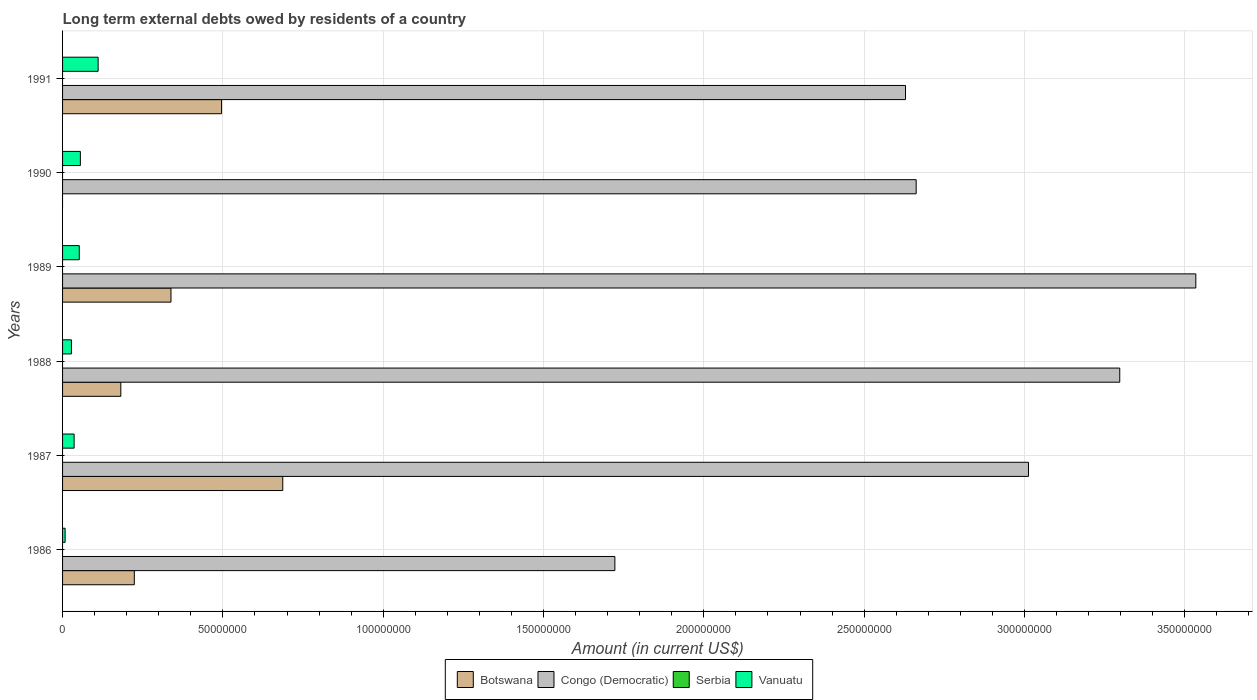How many groups of bars are there?
Ensure brevity in your answer.  6. Are the number of bars on each tick of the Y-axis equal?
Ensure brevity in your answer.  No. How many bars are there on the 4th tick from the bottom?
Give a very brief answer. 3. In how many cases, is the number of bars for a given year not equal to the number of legend labels?
Your response must be concise. 6. What is the amount of long-term external debts owed by residents in Vanuatu in 1986?
Your answer should be compact. 7.98e+05. Across all years, what is the maximum amount of long-term external debts owed by residents in Botswana?
Your response must be concise. 6.87e+07. Across all years, what is the minimum amount of long-term external debts owed by residents in Vanuatu?
Offer a very short reply. 7.98e+05. What is the total amount of long-term external debts owed by residents in Congo (Democratic) in the graph?
Ensure brevity in your answer.  1.69e+09. What is the difference between the amount of long-term external debts owed by residents in Botswana in 1988 and that in 1991?
Your answer should be very brief. -3.14e+07. What is the difference between the amount of long-term external debts owed by residents in Serbia in 1987 and the amount of long-term external debts owed by residents in Congo (Democratic) in 1986?
Your answer should be compact. -1.72e+08. What is the average amount of long-term external debts owed by residents in Vanuatu per year?
Give a very brief answer. 4.84e+06. In the year 1991, what is the difference between the amount of long-term external debts owed by residents in Vanuatu and amount of long-term external debts owed by residents in Botswana?
Give a very brief answer. -3.85e+07. In how many years, is the amount of long-term external debts owed by residents in Vanuatu greater than 10000000 US$?
Your answer should be very brief. 1. What is the ratio of the amount of long-term external debts owed by residents in Congo (Democratic) in 1987 to that in 1990?
Your answer should be very brief. 1.13. What is the difference between the highest and the second highest amount of long-term external debts owed by residents in Botswana?
Your answer should be compact. 1.91e+07. What is the difference between the highest and the lowest amount of long-term external debts owed by residents in Vanuatu?
Your response must be concise. 1.03e+07. In how many years, is the amount of long-term external debts owed by residents in Serbia greater than the average amount of long-term external debts owed by residents in Serbia taken over all years?
Offer a terse response. 0. Is the sum of the amount of long-term external debts owed by residents in Congo (Democratic) in 1987 and 1989 greater than the maximum amount of long-term external debts owed by residents in Serbia across all years?
Give a very brief answer. Yes. How many bars are there?
Ensure brevity in your answer.  17. Does the graph contain any zero values?
Ensure brevity in your answer.  Yes. How many legend labels are there?
Your answer should be compact. 4. How are the legend labels stacked?
Make the answer very short. Horizontal. What is the title of the graph?
Keep it short and to the point. Long term external debts owed by residents of a country. Does "Channel Islands" appear as one of the legend labels in the graph?
Make the answer very short. No. What is the label or title of the Y-axis?
Make the answer very short. Years. What is the Amount (in current US$) of Botswana in 1986?
Your response must be concise. 2.24e+07. What is the Amount (in current US$) in Congo (Democratic) in 1986?
Ensure brevity in your answer.  1.72e+08. What is the Amount (in current US$) of Vanuatu in 1986?
Make the answer very short. 7.98e+05. What is the Amount (in current US$) in Botswana in 1987?
Offer a terse response. 6.87e+07. What is the Amount (in current US$) of Congo (Democratic) in 1987?
Ensure brevity in your answer.  3.01e+08. What is the Amount (in current US$) in Vanuatu in 1987?
Offer a terse response. 3.60e+06. What is the Amount (in current US$) of Botswana in 1988?
Provide a short and direct response. 1.82e+07. What is the Amount (in current US$) in Congo (Democratic) in 1988?
Keep it short and to the point. 3.30e+08. What is the Amount (in current US$) in Serbia in 1988?
Your response must be concise. 0. What is the Amount (in current US$) of Vanuatu in 1988?
Offer a terse response. 2.76e+06. What is the Amount (in current US$) in Botswana in 1989?
Your answer should be compact. 3.38e+07. What is the Amount (in current US$) of Congo (Democratic) in 1989?
Give a very brief answer. 3.53e+08. What is the Amount (in current US$) of Vanuatu in 1989?
Offer a very short reply. 5.21e+06. What is the Amount (in current US$) in Botswana in 1990?
Your answer should be compact. 0. What is the Amount (in current US$) in Congo (Democratic) in 1990?
Your answer should be compact. 2.66e+08. What is the Amount (in current US$) of Vanuatu in 1990?
Keep it short and to the point. 5.56e+06. What is the Amount (in current US$) of Botswana in 1991?
Your response must be concise. 4.96e+07. What is the Amount (in current US$) in Congo (Democratic) in 1991?
Your response must be concise. 2.63e+08. What is the Amount (in current US$) in Vanuatu in 1991?
Your response must be concise. 1.11e+07. Across all years, what is the maximum Amount (in current US$) of Botswana?
Provide a short and direct response. 6.87e+07. Across all years, what is the maximum Amount (in current US$) of Congo (Democratic)?
Your answer should be compact. 3.53e+08. Across all years, what is the maximum Amount (in current US$) in Vanuatu?
Ensure brevity in your answer.  1.11e+07. Across all years, what is the minimum Amount (in current US$) in Congo (Democratic)?
Your answer should be very brief. 1.72e+08. Across all years, what is the minimum Amount (in current US$) in Vanuatu?
Give a very brief answer. 7.98e+05. What is the total Amount (in current US$) in Botswana in the graph?
Ensure brevity in your answer.  1.93e+08. What is the total Amount (in current US$) in Congo (Democratic) in the graph?
Offer a terse response. 1.69e+09. What is the total Amount (in current US$) of Vanuatu in the graph?
Your response must be concise. 2.90e+07. What is the difference between the Amount (in current US$) of Botswana in 1986 and that in 1987?
Make the answer very short. -4.63e+07. What is the difference between the Amount (in current US$) in Congo (Democratic) in 1986 and that in 1987?
Keep it short and to the point. -1.29e+08. What is the difference between the Amount (in current US$) in Vanuatu in 1986 and that in 1987?
Your response must be concise. -2.81e+06. What is the difference between the Amount (in current US$) in Botswana in 1986 and that in 1988?
Provide a short and direct response. 4.21e+06. What is the difference between the Amount (in current US$) of Congo (Democratic) in 1986 and that in 1988?
Your response must be concise. -1.57e+08. What is the difference between the Amount (in current US$) in Vanuatu in 1986 and that in 1988?
Ensure brevity in your answer.  -1.96e+06. What is the difference between the Amount (in current US$) of Botswana in 1986 and that in 1989?
Make the answer very short. -1.14e+07. What is the difference between the Amount (in current US$) of Congo (Democratic) in 1986 and that in 1989?
Your response must be concise. -1.81e+08. What is the difference between the Amount (in current US$) of Vanuatu in 1986 and that in 1989?
Your response must be concise. -4.41e+06. What is the difference between the Amount (in current US$) in Congo (Democratic) in 1986 and that in 1990?
Keep it short and to the point. -9.40e+07. What is the difference between the Amount (in current US$) of Vanuatu in 1986 and that in 1990?
Provide a succinct answer. -4.76e+06. What is the difference between the Amount (in current US$) of Botswana in 1986 and that in 1991?
Ensure brevity in your answer.  -2.72e+07. What is the difference between the Amount (in current US$) in Congo (Democratic) in 1986 and that in 1991?
Your response must be concise. -9.06e+07. What is the difference between the Amount (in current US$) of Vanuatu in 1986 and that in 1991?
Provide a short and direct response. -1.03e+07. What is the difference between the Amount (in current US$) of Botswana in 1987 and that in 1988?
Your answer should be very brief. 5.05e+07. What is the difference between the Amount (in current US$) in Congo (Democratic) in 1987 and that in 1988?
Offer a terse response. -2.85e+07. What is the difference between the Amount (in current US$) of Vanuatu in 1987 and that in 1988?
Your answer should be very brief. 8.45e+05. What is the difference between the Amount (in current US$) in Botswana in 1987 and that in 1989?
Ensure brevity in your answer.  3.49e+07. What is the difference between the Amount (in current US$) in Congo (Democratic) in 1987 and that in 1989?
Keep it short and to the point. -5.22e+07. What is the difference between the Amount (in current US$) in Vanuatu in 1987 and that in 1989?
Offer a terse response. -1.60e+06. What is the difference between the Amount (in current US$) of Congo (Democratic) in 1987 and that in 1990?
Offer a very short reply. 3.50e+07. What is the difference between the Amount (in current US$) of Vanuatu in 1987 and that in 1990?
Your response must be concise. -1.95e+06. What is the difference between the Amount (in current US$) of Botswana in 1987 and that in 1991?
Make the answer very short. 1.91e+07. What is the difference between the Amount (in current US$) in Congo (Democratic) in 1987 and that in 1991?
Your answer should be very brief. 3.83e+07. What is the difference between the Amount (in current US$) in Vanuatu in 1987 and that in 1991?
Make the answer very short. -7.49e+06. What is the difference between the Amount (in current US$) of Botswana in 1988 and that in 1989?
Provide a succinct answer. -1.56e+07. What is the difference between the Amount (in current US$) of Congo (Democratic) in 1988 and that in 1989?
Ensure brevity in your answer.  -2.37e+07. What is the difference between the Amount (in current US$) in Vanuatu in 1988 and that in 1989?
Keep it short and to the point. -2.45e+06. What is the difference between the Amount (in current US$) in Congo (Democratic) in 1988 and that in 1990?
Ensure brevity in your answer.  6.35e+07. What is the difference between the Amount (in current US$) in Vanuatu in 1988 and that in 1990?
Your answer should be very brief. -2.80e+06. What is the difference between the Amount (in current US$) in Botswana in 1988 and that in 1991?
Keep it short and to the point. -3.14e+07. What is the difference between the Amount (in current US$) in Congo (Democratic) in 1988 and that in 1991?
Your response must be concise. 6.68e+07. What is the difference between the Amount (in current US$) of Vanuatu in 1988 and that in 1991?
Offer a terse response. -8.33e+06. What is the difference between the Amount (in current US$) in Congo (Democratic) in 1989 and that in 1990?
Provide a short and direct response. 8.72e+07. What is the difference between the Amount (in current US$) in Vanuatu in 1989 and that in 1990?
Offer a very short reply. -3.47e+05. What is the difference between the Amount (in current US$) in Botswana in 1989 and that in 1991?
Provide a succinct answer. -1.58e+07. What is the difference between the Amount (in current US$) of Congo (Democratic) in 1989 and that in 1991?
Your answer should be very brief. 9.05e+07. What is the difference between the Amount (in current US$) in Vanuatu in 1989 and that in 1991?
Keep it short and to the point. -5.89e+06. What is the difference between the Amount (in current US$) of Congo (Democratic) in 1990 and that in 1991?
Offer a terse response. 3.32e+06. What is the difference between the Amount (in current US$) in Vanuatu in 1990 and that in 1991?
Provide a short and direct response. -5.54e+06. What is the difference between the Amount (in current US$) in Botswana in 1986 and the Amount (in current US$) in Congo (Democratic) in 1987?
Give a very brief answer. -2.79e+08. What is the difference between the Amount (in current US$) of Botswana in 1986 and the Amount (in current US$) of Vanuatu in 1987?
Your response must be concise. 1.88e+07. What is the difference between the Amount (in current US$) of Congo (Democratic) in 1986 and the Amount (in current US$) of Vanuatu in 1987?
Your answer should be compact. 1.69e+08. What is the difference between the Amount (in current US$) in Botswana in 1986 and the Amount (in current US$) in Congo (Democratic) in 1988?
Your answer should be compact. -3.07e+08. What is the difference between the Amount (in current US$) in Botswana in 1986 and the Amount (in current US$) in Vanuatu in 1988?
Offer a terse response. 1.96e+07. What is the difference between the Amount (in current US$) of Congo (Democratic) in 1986 and the Amount (in current US$) of Vanuatu in 1988?
Offer a very short reply. 1.69e+08. What is the difference between the Amount (in current US$) in Botswana in 1986 and the Amount (in current US$) in Congo (Democratic) in 1989?
Your response must be concise. -3.31e+08. What is the difference between the Amount (in current US$) of Botswana in 1986 and the Amount (in current US$) of Vanuatu in 1989?
Keep it short and to the point. 1.72e+07. What is the difference between the Amount (in current US$) in Congo (Democratic) in 1986 and the Amount (in current US$) in Vanuatu in 1989?
Give a very brief answer. 1.67e+08. What is the difference between the Amount (in current US$) in Botswana in 1986 and the Amount (in current US$) in Congo (Democratic) in 1990?
Offer a very short reply. -2.44e+08. What is the difference between the Amount (in current US$) of Botswana in 1986 and the Amount (in current US$) of Vanuatu in 1990?
Your response must be concise. 1.68e+07. What is the difference between the Amount (in current US$) in Congo (Democratic) in 1986 and the Amount (in current US$) in Vanuatu in 1990?
Ensure brevity in your answer.  1.67e+08. What is the difference between the Amount (in current US$) of Botswana in 1986 and the Amount (in current US$) of Congo (Democratic) in 1991?
Your response must be concise. -2.41e+08. What is the difference between the Amount (in current US$) in Botswana in 1986 and the Amount (in current US$) in Vanuatu in 1991?
Your answer should be compact. 1.13e+07. What is the difference between the Amount (in current US$) of Congo (Democratic) in 1986 and the Amount (in current US$) of Vanuatu in 1991?
Your answer should be compact. 1.61e+08. What is the difference between the Amount (in current US$) in Botswana in 1987 and the Amount (in current US$) in Congo (Democratic) in 1988?
Provide a succinct answer. -2.61e+08. What is the difference between the Amount (in current US$) in Botswana in 1987 and the Amount (in current US$) in Vanuatu in 1988?
Give a very brief answer. 6.59e+07. What is the difference between the Amount (in current US$) of Congo (Democratic) in 1987 and the Amount (in current US$) of Vanuatu in 1988?
Offer a terse response. 2.98e+08. What is the difference between the Amount (in current US$) in Botswana in 1987 and the Amount (in current US$) in Congo (Democratic) in 1989?
Your answer should be compact. -2.85e+08. What is the difference between the Amount (in current US$) in Botswana in 1987 and the Amount (in current US$) in Vanuatu in 1989?
Offer a terse response. 6.35e+07. What is the difference between the Amount (in current US$) in Congo (Democratic) in 1987 and the Amount (in current US$) in Vanuatu in 1989?
Offer a very short reply. 2.96e+08. What is the difference between the Amount (in current US$) in Botswana in 1987 and the Amount (in current US$) in Congo (Democratic) in 1990?
Offer a terse response. -1.98e+08. What is the difference between the Amount (in current US$) in Botswana in 1987 and the Amount (in current US$) in Vanuatu in 1990?
Provide a short and direct response. 6.31e+07. What is the difference between the Amount (in current US$) in Congo (Democratic) in 1987 and the Amount (in current US$) in Vanuatu in 1990?
Your answer should be very brief. 2.96e+08. What is the difference between the Amount (in current US$) of Botswana in 1987 and the Amount (in current US$) of Congo (Democratic) in 1991?
Your answer should be very brief. -1.94e+08. What is the difference between the Amount (in current US$) in Botswana in 1987 and the Amount (in current US$) in Vanuatu in 1991?
Provide a short and direct response. 5.76e+07. What is the difference between the Amount (in current US$) of Congo (Democratic) in 1987 and the Amount (in current US$) of Vanuatu in 1991?
Your response must be concise. 2.90e+08. What is the difference between the Amount (in current US$) of Botswana in 1988 and the Amount (in current US$) of Congo (Democratic) in 1989?
Keep it short and to the point. -3.35e+08. What is the difference between the Amount (in current US$) of Botswana in 1988 and the Amount (in current US$) of Vanuatu in 1989?
Keep it short and to the point. 1.30e+07. What is the difference between the Amount (in current US$) in Congo (Democratic) in 1988 and the Amount (in current US$) in Vanuatu in 1989?
Your response must be concise. 3.25e+08. What is the difference between the Amount (in current US$) of Botswana in 1988 and the Amount (in current US$) of Congo (Democratic) in 1990?
Offer a terse response. -2.48e+08. What is the difference between the Amount (in current US$) of Botswana in 1988 and the Amount (in current US$) of Vanuatu in 1990?
Provide a succinct answer. 1.26e+07. What is the difference between the Amount (in current US$) in Congo (Democratic) in 1988 and the Amount (in current US$) in Vanuatu in 1990?
Keep it short and to the point. 3.24e+08. What is the difference between the Amount (in current US$) of Botswana in 1988 and the Amount (in current US$) of Congo (Democratic) in 1991?
Provide a succinct answer. -2.45e+08. What is the difference between the Amount (in current US$) of Botswana in 1988 and the Amount (in current US$) of Vanuatu in 1991?
Offer a very short reply. 7.08e+06. What is the difference between the Amount (in current US$) of Congo (Democratic) in 1988 and the Amount (in current US$) of Vanuatu in 1991?
Provide a succinct answer. 3.19e+08. What is the difference between the Amount (in current US$) of Botswana in 1989 and the Amount (in current US$) of Congo (Democratic) in 1990?
Provide a short and direct response. -2.32e+08. What is the difference between the Amount (in current US$) in Botswana in 1989 and the Amount (in current US$) in Vanuatu in 1990?
Provide a succinct answer. 2.83e+07. What is the difference between the Amount (in current US$) of Congo (Democratic) in 1989 and the Amount (in current US$) of Vanuatu in 1990?
Offer a very short reply. 3.48e+08. What is the difference between the Amount (in current US$) of Botswana in 1989 and the Amount (in current US$) of Congo (Democratic) in 1991?
Your answer should be compact. -2.29e+08. What is the difference between the Amount (in current US$) of Botswana in 1989 and the Amount (in current US$) of Vanuatu in 1991?
Your answer should be compact. 2.27e+07. What is the difference between the Amount (in current US$) in Congo (Democratic) in 1989 and the Amount (in current US$) in Vanuatu in 1991?
Offer a terse response. 3.42e+08. What is the difference between the Amount (in current US$) in Congo (Democratic) in 1990 and the Amount (in current US$) in Vanuatu in 1991?
Make the answer very short. 2.55e+08. What is the average Amount (in current US$) in Botswana per year?
Offer a terse response. 3.21e+07. What is the average Amount (in current US$) in Congo (Democratic) per year?
Ensure brevity in your answer.  2.81e+08. What is the average Amount (in current US$) of Serbia per year?
Provide a succinct answer. 0. What is the average Amount (in current US$) in Vanuatu per year?
Provide a short and direct response. 4.84e+06. In the year 1986, what is the difference between the Amount (in current US$) in Botswana and Amount (in current US$) in Congo (Democratic)?
Your response must be concise. -1.50e+08. In the year 1986, what is the difference between the Amount (in current US$) in Botswana and Amount (in current US$) in Vanuatu?
Provide a succinct answer. 2.16e+07. In the year 1986, what is the difference between the Amount (in current US$) in Congo (Democratic) and Amount (in current US$) in Vanuatu?
Ensure brevity in your answer.  1.71e+08. In the year 1987, what is the difference between the Amount (in current US$) of Botswana and Amount (in current US$) of Congo (Democratic)?
Your answer should be compact. -2.33e+08. In the year 1987, what is the difference between the Amount (in current US$) of Botswana and Amount (in current US$) of Vanuatu?
Keep it short and to the point. 6.51e+07. In the year 1987, what is the difference between the Amount (in current US$) of Congo (Democratic) and Amount (in current US$) of Vanuatu?
Your answer should be compact. 2.98e+08. In the year 1988, what is the difference between the Amount (in current US$) of Botswana and Amount (in current US$) of Congo (Democratic)?
Provide a succinct answer. -3.12e+08. In the year 1988, what is the difference between the Amount (in current US$) in Botswana and Amount (in current US$) in Vanuatu?
Keep it short and to the point. 1.54e+07. In the year 1988, what is the difference between the Amount (in current US$) in Congo (Democratic) and Amount (in current US$) in Vanuatu?
Keep it short and to the point. 3.27e+08. In the year 1989, what is the difference between the Amount (in current US$) of Botswana and Amount (in current US$) of Congo (Democratic)?
Provide a succinct answer. -3.20e+08. In the year 1989, what is the difference between the Amount (in current US$) of Botswana and Amount (in current US$) of Vanuatu?
Provide a succinct answer. 2.86e+07. In the year 1989, what is the difference between the Amount (in current US$) of Congo (Democratic) and Amount (in current US$) of Vanuatu?
Make the answer very short. 3.48e+08. In the year 1990, what is the difference between the Amount (in current US$) of Congo (Democratic) and Amount (in current US$) of Vanuatu?
Offer a terse response. 2.61e+08. In the year 1991, what is the difference between the Amount (in current US$) of Botswana and Amount (in current US$) of Congo (Democratic)?
Give a very brief answer. -2.13e+08. In the year 1991, what is the difference between the Amount (in current US$) in Botswana and Amount (in current US$) in Vanuatu?
Make the answer very short. 3.85e+07. In the year 1991, what is the difference between the Amount (in current US$) in Congo (Democratic) and Amount (in current US$) in Vanuatu?
Offer a terse response. 2.52e+08. What is the ratio of the Amount (in current US$) in Botswana in 1986 to that in 1987?
Provide a short and direct response. 0.33. What is the ratio of the Amount (in current US$) in Congo (Democratic) in 1986 to that in 1987?
Give a very brief answer. 0.57. What is the ratio of the Amount (in current US$) of Vanuatu in 1986 to that in 1987?
Keep it short and to the point. 0.22. What is the ratio of the Amount (in current US$) in Botswana in 1986 to that in 1988?
Your answer should be compact. 1.23. What is the ratio of the Amount (in current US$) of Congo (Democratic) in 1986 to that in 1988?
Offer a very short reply. 0.52. What is the ratio of the Amount (in current US$) in Vanuatu in 1986 to that in 1988?
Ensure brevity in your answer.  0.29. What is the ratio of the Amount (in current US$) in Botswana in 1986 to that in 1989?
Your answer should be compact. 0.66. What is the ratio of the Amount (in current US$) of Congo (Democratic) in 1986 to that in 1989?
Your answer should be very brief. 0.49. What is the ratio of the Amount (in current US$) in Vanuatu in 1986 to that in 1989?
Provide a succinct answer. 0.15. What is the ratio of the Amount (in current US$) in Congo (Democratic) in 1986 to that in 1990?
Provide a short and direct response. 0.65. What is the ratio of the Amount (in current US$) in Vanuatu in 1986 to that in 1990?
Your response must be concise. 0.14. What is the ratio of the Amount (in current US$) in Botswana in 1986 to that in 1991?
Keep it short and to the point. 0.45. What is the ratio of the Amount (in current US$) of Congo (Democratic) in 1986 to that in 1991?
Make the answer very short. 0.66. What is the ratio of the Amount (in current US$) of Vanuatu in 1986 to that in 1991?
Offer a terse response. 0.07. What is the ratio of the Amount (in current US$) of Botswana in 1987 to that in 1988?
Your response must be concise. 3.78. What is the ratio of the Amount (in current US$) of Congo (Democratic) in 1987 to that in 1988?
Provide a succinct answer. 0.91. What is the ratio of the Amount (in current US$) in Vanuatu in 1987 to that in 1988?
Provide a succinct answer. 1.31. What is the ratio of the Amount (in current US$) of Botswana in 1987 to that in 1989?
Offer a terse response. 2.03. What is the ratio of the Amount (in current US$) of Congo (Democratic) in 1987 to that in 1989?
Your response must be concise. 0.85. What is the ratio of the Amount (in current US$) in Vanuatu in 1987 to that in 1989?
Provide a succinct answer. 0.69. What is the ratio of the Amount (in current US$) of Congo (Democratic) in 1987 to that in 1990?
Keep it short and to the point. 1.13. What is the ratio of the Amount (in current US$) of Vanuatu in 1987 to that in 1990?
Your response must be concise. 0.65. What is the ratio of the Amount (in current US$) of Botswana in 1987 to that in 1991?
Make the answer very short. 1.38. What is the ratio of the Amount (in current US$) in Congo (Democratic) in 1987 to that in 1991?
Provide a succinct answer. 1.15. What is the ratio of the Amount (in current US$) of Vanuatu in 1987 to that in 1991?
Make the answer very short. 0.33. What is the ratio of the Amount (in current US$) in Botswana in 1988 to that in 1989?
Offer a terse response. 0.54. What is the ratio of the Amount (in current US$) of Congo (Democratic) in 1988 to that in 1989?
Keep it short and to the point. 0.93. What is the ratio of the Amount (in current US$) in Vanuatu in 1988 to that in 1989?
Your answer should be very brief. 0.53. What is the ratio of the Amount (in current US$) in Congo (Democratic) in 1988 to that in 1990?
Your answer should be compact. 1.24. What is the ratio of the Amount (in current US$) of Vanuatu in 1988 to that in 1990?
Your answer should be compact. 0.5. What is the ratio of the Amount (in current US$) in Botswana in 1988 to that in 1991?
Offer a very short reply. 0.37. What is the ratio of the Amount (in current US$) of Congo (Democratic) in 1988 to that in 1991?
Give a very brief answer. 1.25. What is the ratio of the Amount (in current US$) of Vanuatu in 1988 to that in 1991?
Make the answer very short. 0.25. What is the ratio of the Amount (in current US$) of Congo (Democratic) in 1989 to that in 1990?
Keep it short and to the point. 1.33. What is the ratio of the Amount (in current US$) of Vanuatu in 1989 to that in 1990?
Offer a terse response. 0.94. What is the ratio of the Amount (in current US$) of Botswana in 1989 to that in 1991?
Your answer should be very brief. 0.68. What is the ratio of the Amount (in current US$) in Congo (Democratic) in 1989 to that in 1991?
Provide a short and direct response. 1.34. What is the ratio of the Amount (in current US$) in Vanuatu in 1989 to that in 1991?
Your answer should be very brief. 0.47. What is the ratio of the Amount (in current US$) in Congo (Democratic) in 1990 to that in 1991?
Offer a terse response. 1.01. What is the ratio of the Amount (in current US$) in Vanuatu in 1990 to that in 1991?
Offer a very short reply. 0.5. What is the difference between the highest and the second highest Amount (in current US$) of Botswana?
Give a very brief answer. 1.91e+07. What is the difference between the highest and the second highest Amount (in current US$) of Congo (Democratic)?
Provide a short and direct response. 2.37e+07. What is the difference between the highest and the second highest Amount (in current US$) in Vanuatu?
Give a very brief answer. 5.54e+06. What is the difference between the highest and the lowest Amount (in current US$) of Botswana?
Provide a succinct answer. 6.87e+07. What is the difference between the highest and the lowest Amount (in current US$) in Congo (Democratic)?
Keep it short and to the point. 1.81e+08. What is the difference between the highest and the lowest Amount (in current US$) in Vanuatu?
Your answer should be compact. 1.03e+07. 